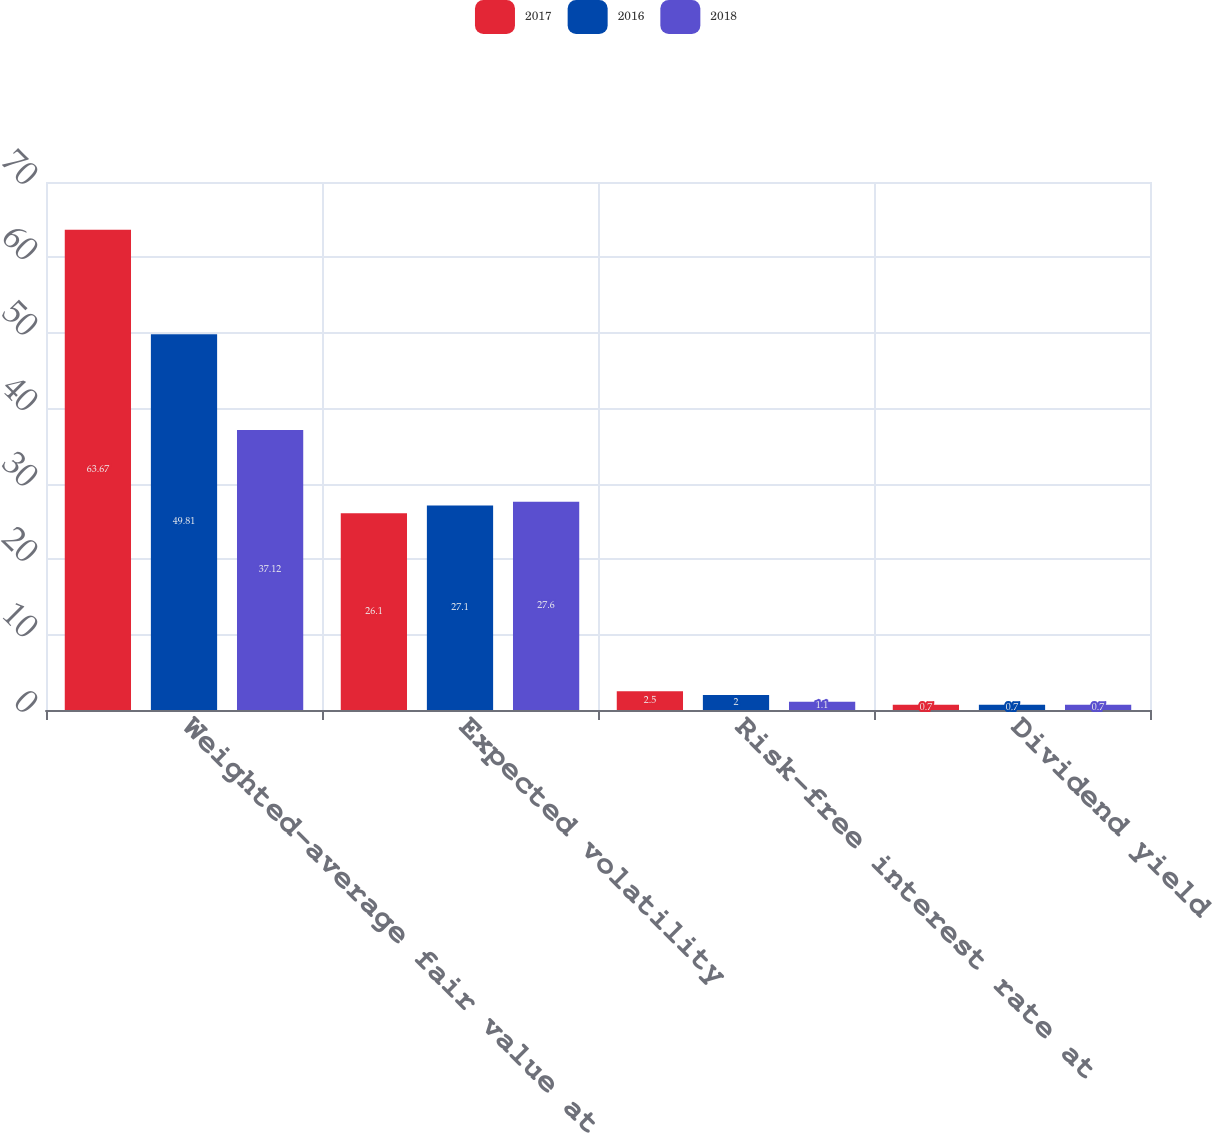Convert chart to OTSL. <chart><loc_0><loc_0><loc_500><loc_500><stacked_bar_chart><ecel><fcel>Weighted-average fair value at<fcel>Expected volatility<fcel>Risk-free interest rate at<fcel>Dividend yield<nl><fcel>2017<fcel>63.67<fcel>26.1<fcel>2.5<fcel>0.7<nl><fcel>2016<fcel>49.81<fcel>27.1<fcel>2<fcel>0.7<nl><fcel>2018<fcel>37.12<fcel>27.6<fcel>1.1<fcel>0.7<nl></chart> 